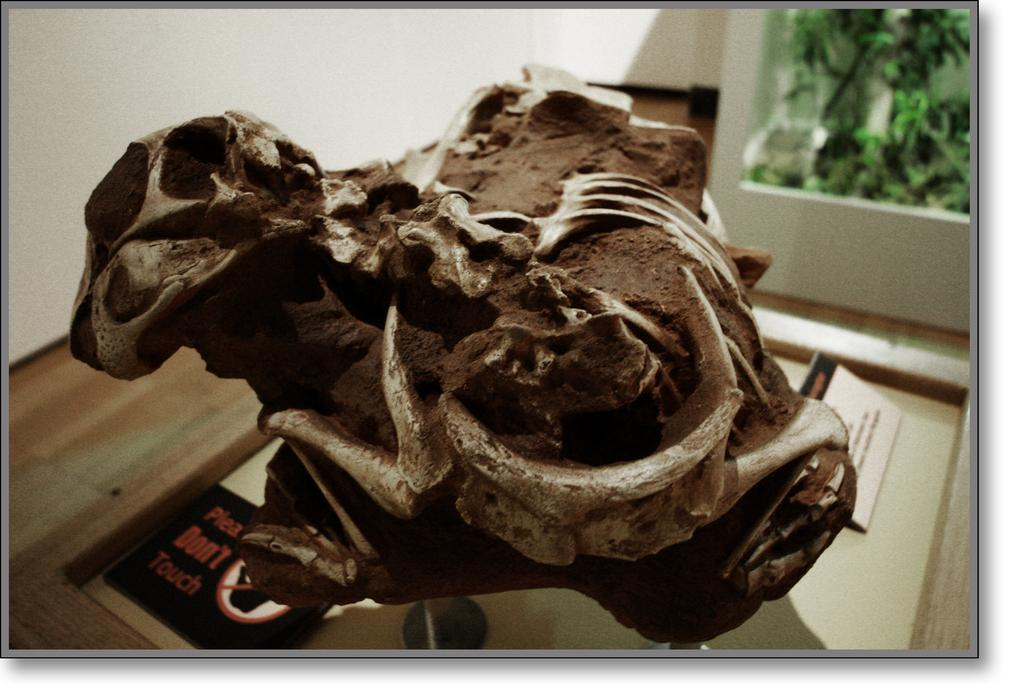What is the main subject in the center of the image? There is a brown object in the center of the image. What can be seen in the background of the image? There are trees in the background of the image. What type of furniture is present in the image? There is no furniture present in the image; it only features a brown object and trees in the background. 